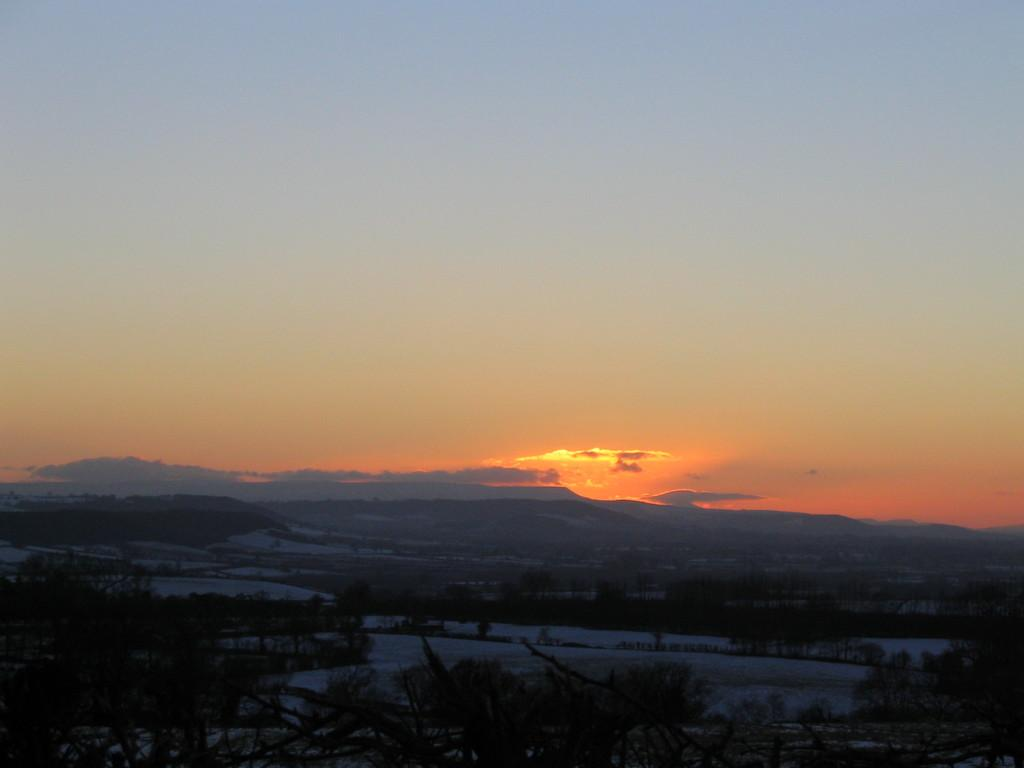What type of living organisms can be seen in the image? Plants can be seen in the image. What is the primary element visible in the image? Water is visible in the image. What can be seen in the background of the image? There is a hill and the sky visible in the background of the image. What is the condition of the sky in the image? Sunshine is present in the sky. How much money is being exchanged between the plants in the image? There is no money present in the image, as it features plants and water. What type of toys can be seen in the image? There are no toys present in the image; it features plants, water, a hill, and the sky. 